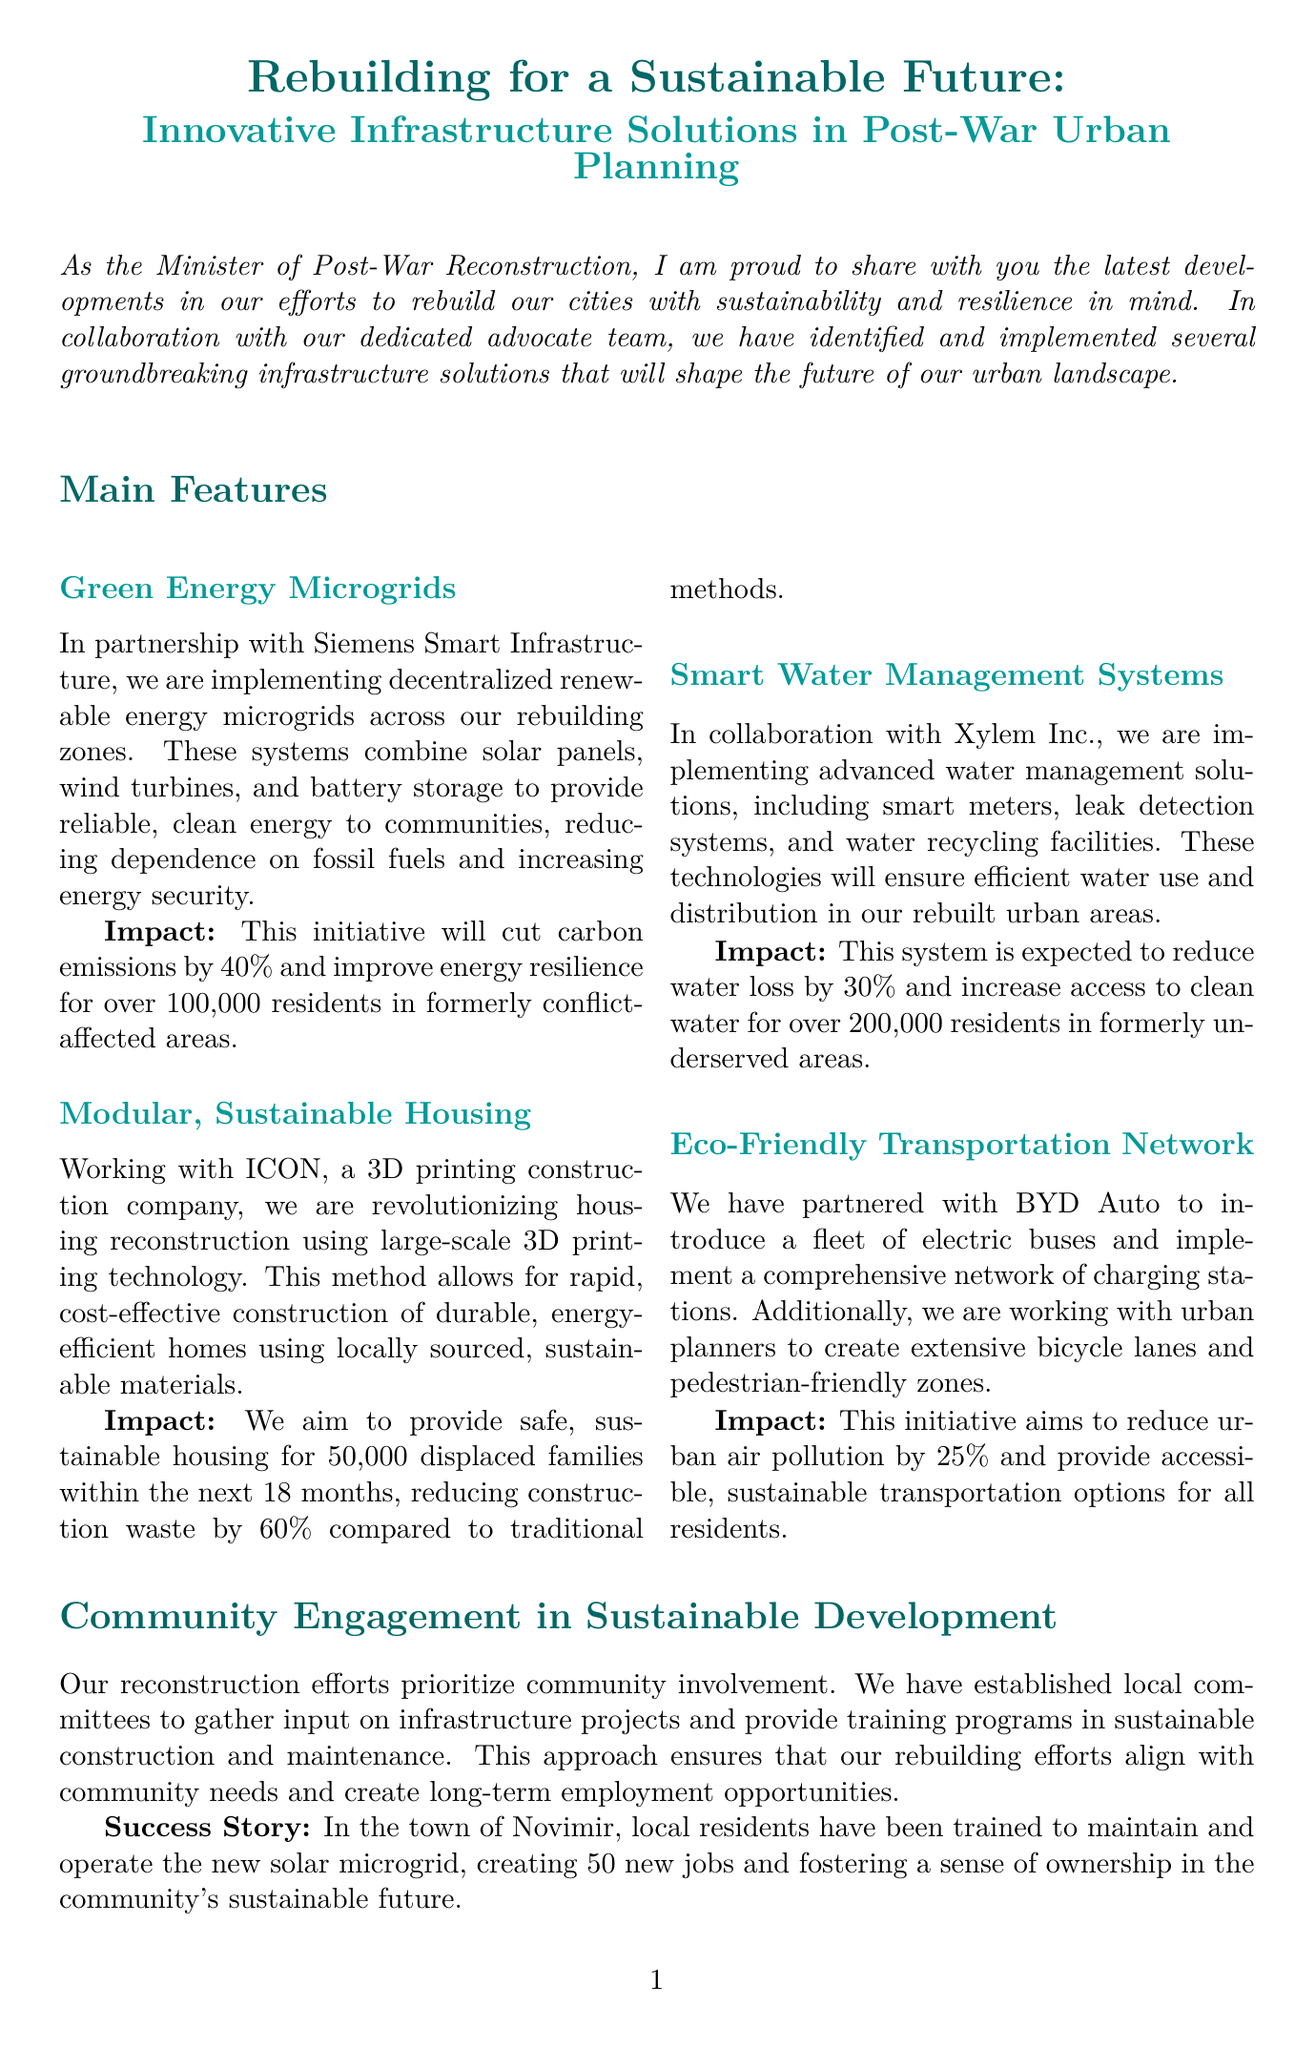What is the title of the newsletter? The title of the newsletter is provided in the document's header.
Answer: Rebuilding for a Sustainable Future: Innovative Infrastructure Solutions in Post-War Urban Planning Who is partnering with Siemens Smart Infrastructure? The document specifies partnerships in infrastructure initiatives, including the one with Siemens.
Answer: Siemens Smart Infrastructure How many residents will benefit from the Green Energy Microgrids? The impact section for the microgrid technology states the number of residents affected.
Answer: 100,000 residents What percentage of carbon emissions will be cut by the Green Energy Microgrids? The document lists specific impacts of projects, including the carbon emissions reduction rate for microgrids.
Answer: 40% How many displaced families are targeted for housing through Modular, Sustainable Housing? The impact for modular housing indicates the specific number of families to be provided housing.
Answer: 50,000 displaced families What is the expected reduction in water loss from the Smart Water Management Systems? The impact statement for smart water technology includes the expected water loss reduction percentage.
Answer: 30% What is the upcoming project mentioned for next month? The document specifies an upcoming project related to sustainability and flood management.
Answer: Sponge city project What is the success story highlighted in the community involvement section? The community engagement section includes a specific success story about local training and job creation.
Answer: Local residents have been trained to maintain and operate the new solar microgrid, creating 50 new jobs 